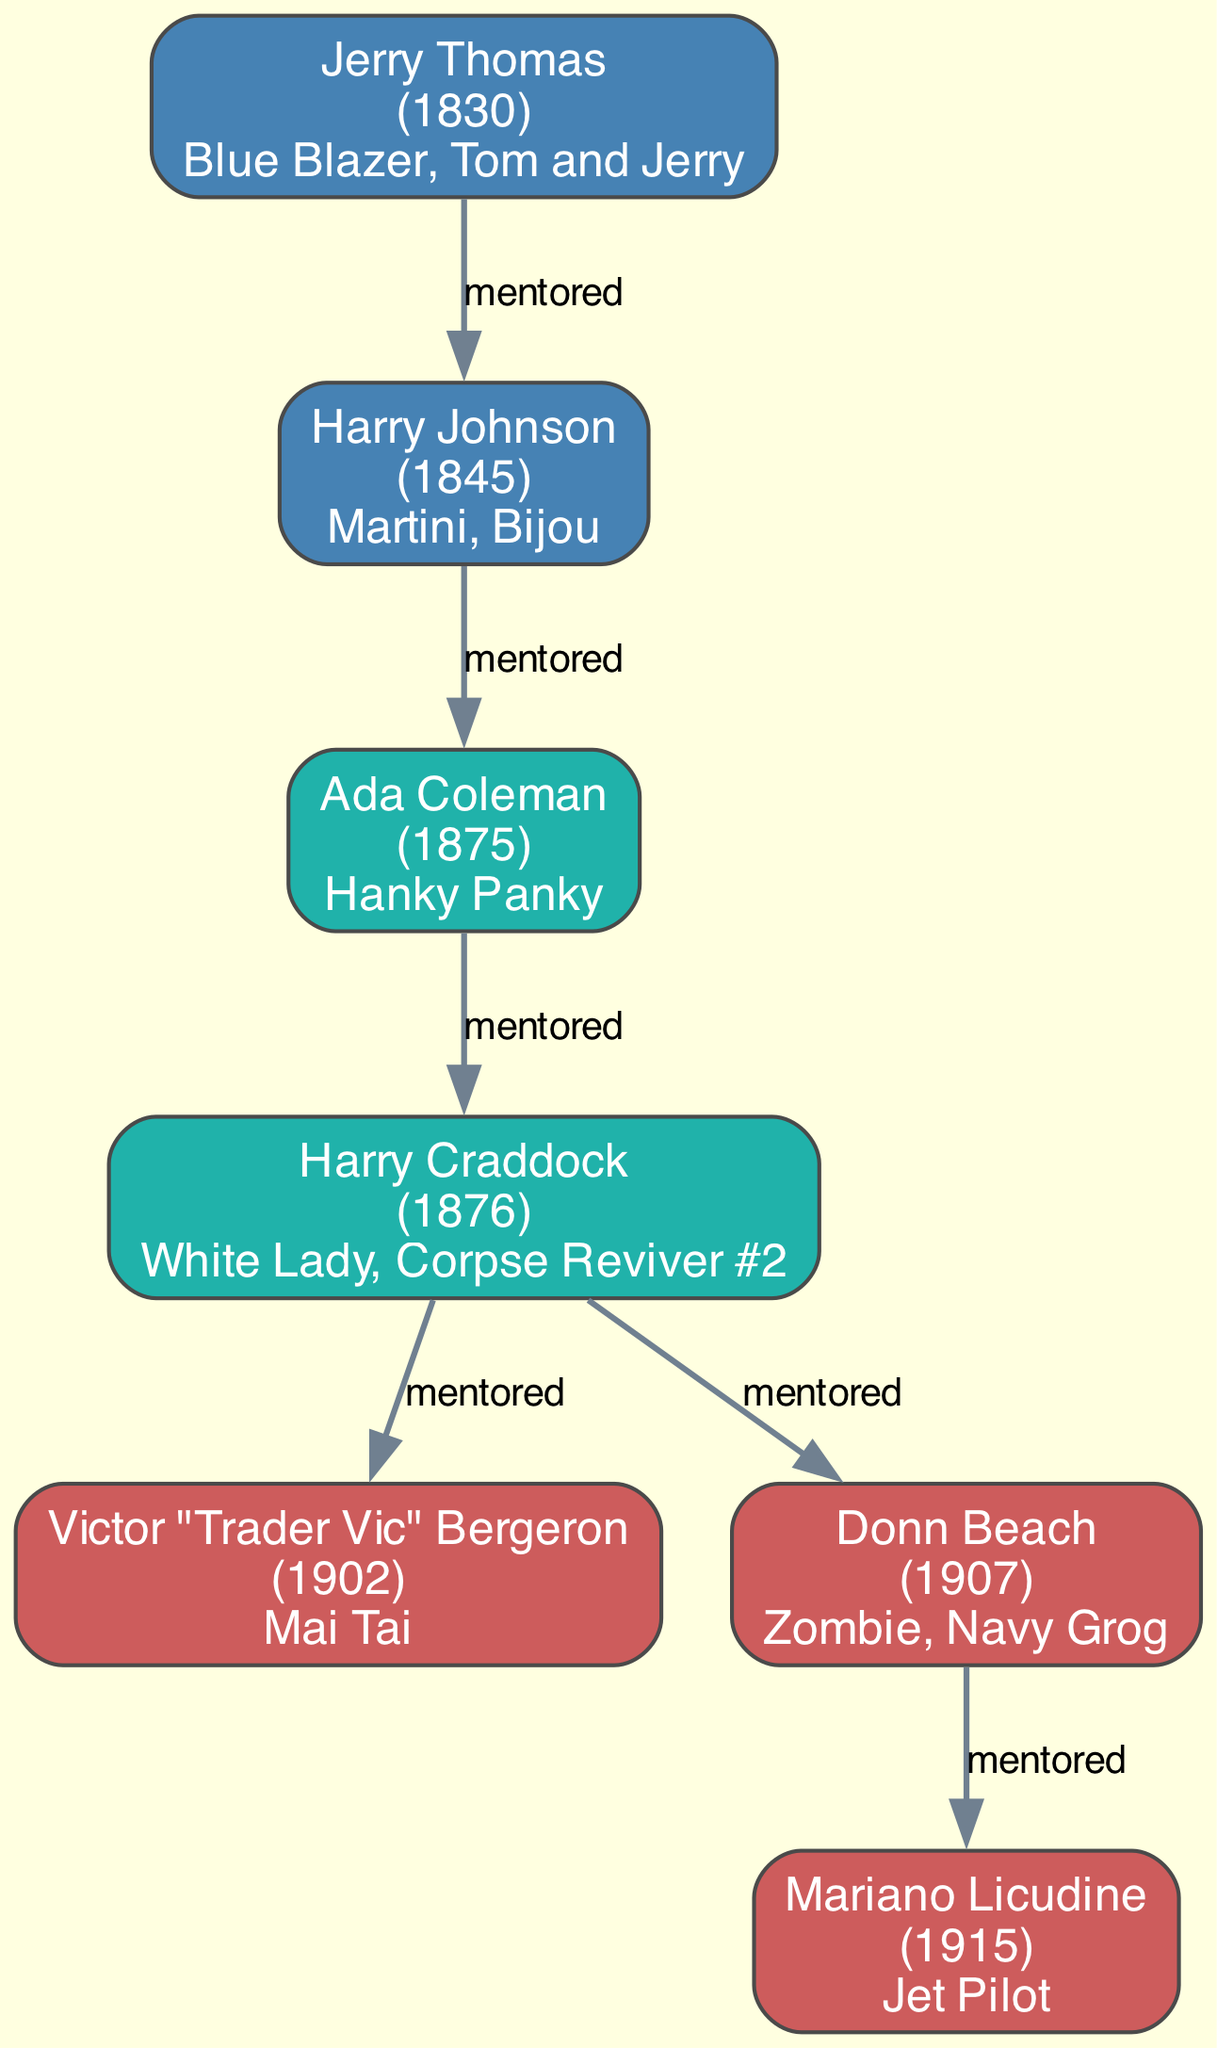What is the birth year of Jerry Thomas? The diagram provides the birth year for each mixologist listed. Looking for Jerry Thomas, the information indicates that his birth year is 1830.
Answer: 1830 Which drink is associated with Ada Coleman? The diagram shows signature drinks for each mixologist. For Ada Coleman, it states that her signature drink is "Hanky Panky."
Answer: Hanky Panky Who mentored Harry Craddock? The relationships in the diagram establish a mentorship flow. Checking Harry Craddock’s entry reveals that he was mentored by Ada Coleman.
Answer: Ada Coleman How many mixologists were born in the 1800s? By examining the birth years of the mixologists in the diagram, we count those born between 1800 and 1899. The mixologists fitting this criterion are Jerry Thomas, Harry Johnson, Ada Coleman, and Harry Craddock, totaling four.
Answer: 4 What is the signature drink of Donn Beach? The diagram lists the signature drinks for each mixologist. For Donn Beach, it indicates that his signature drinks are "Zombie" and "Navy Grog."
Answer: Zombie, Navy Grog Who is the oldest mixologist in the diagram? To determine the oldest mixologist, we compare the birth years of all the listed mixologists. The earliest birth year belongs to Jerry Thomas at 1830, making him the oldest.
Answer: Jerry Thomas How many mixologists did Harry Craddock mentor? The diagram indicates the mentorship relationships for each mixologist, specifically for Harry Craddock, whose entry shows he mentored two individuals: Victor "Trader Vic" Bergeron and Donn Beach.
Answer: 2 Which mixologist has the signature drink "Mai Tai"? The diagram specifies signature drinks next to each mixologist. "Mai Tai" is attributed to Victor "Trader Vic" Bergeron.
Answer: Victor "Trader Vic" Bergeron What relationship connects Harry Johnson and Ada Coleman? By examining the mentorship connections in the diagram, it is clear that Harry Johnson mentored Ada Coleman, indicating a direct mentoring relationship.
Answer: Mentored by 